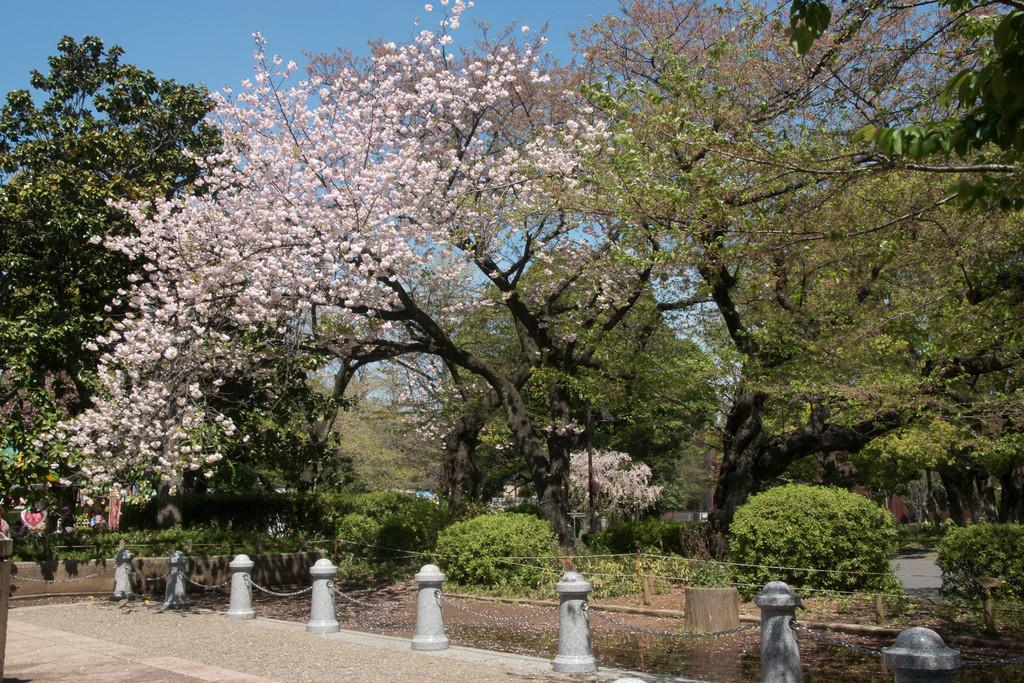What is the main feature of the image? There is a road in the image. What else can be seen along the road? There are poles and chains visible in the image. What type of vegetation is present in the image? There are plants and trees in the image. What can be seen in the background of the image? The sky is visible in the background of the image. What type of soda is being advertised on the poles in the image? There is no soda being advertised on the poles in the image; the poles are simply part of the road infrastructure. How many stitches are visible on the plants in the image? There are no stitches visible on the plants in the image; they are natural vegetation. 